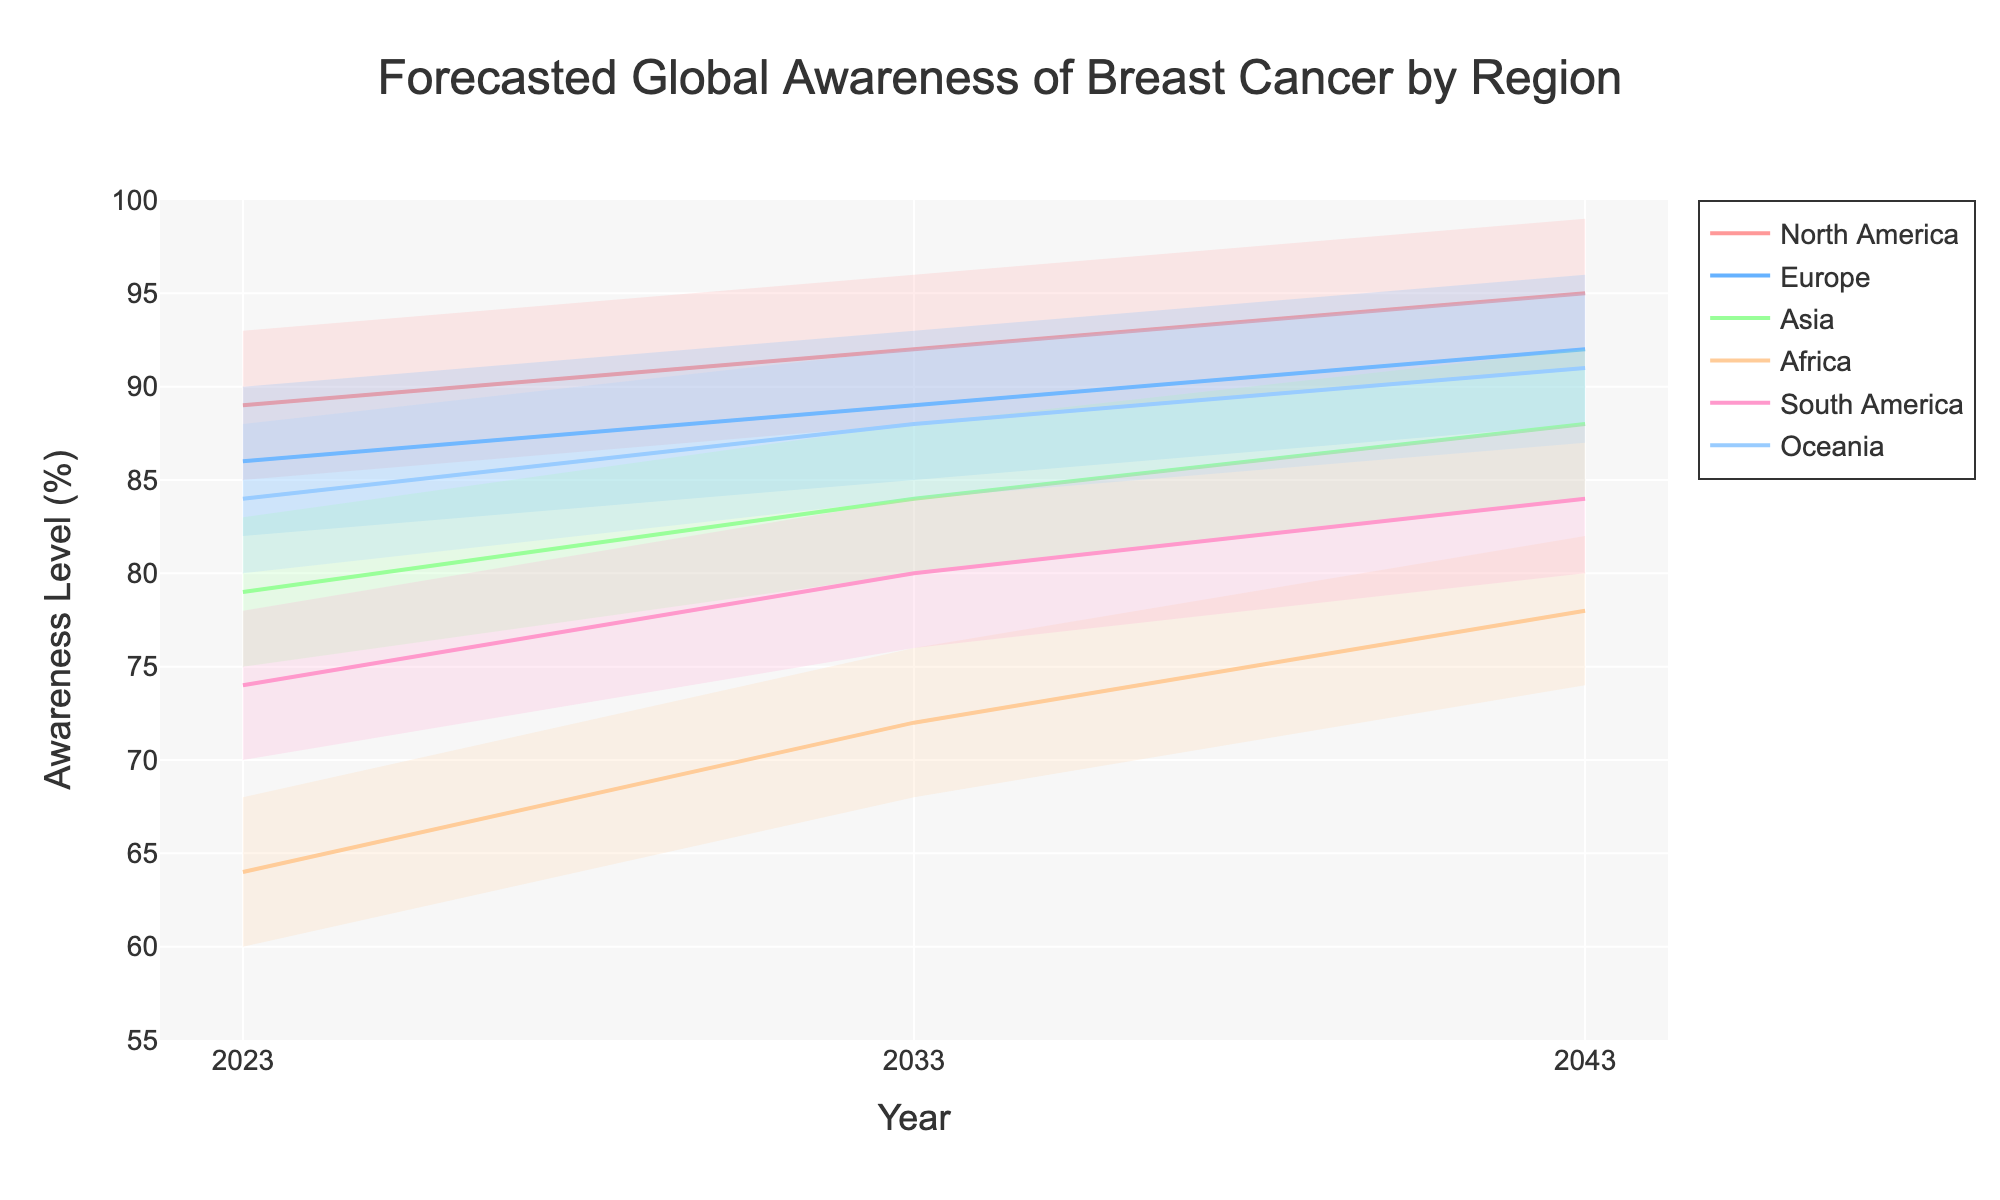What is the title of the chart? The chart title is usually located at the top-center and is written in a larger font. By looking at the top of the chart, we can see that the title is "Forecasted Global Awareness of Breast Cancer by Region".
Answer: Forecasted Global Awareness of Breast Cancer by Region Which region has the highest median awareness level in 2043? To find the highest median awareness level, we need to look at the mid-point values for each region in the year 2043. North America has a mid-point awareness level of 95, which is the highest among all regions.
Answer: North America What trend do you notice for breast cancer awareness levels in Africa from 2023 to 2043? By examining the mid-point values for Africa across the years, we can see an upward trend: 64 in 2023, 72 in 2033, and 78 in 2043. This indicates a steady increase in breast cancer awareness over the 20-year period.
Answer: Increasing trend Which region shows the least amount of increase in awareness levels from 2023 to 2043? To determine which region has the least increase, we need to calculate the difference between 2043 and 2023 mid-point values for each region. For North America: 95 - 89 = 6, Europe: 92 - 86 = 6, Asia: 88 - 79 = 9, Africa: 78 - 64 = 14, South America: 84 - 74 = 10, Oceania: 91 - 84 = 7.  Both North America and Europe have the smallest increase of 6.
Answer: North America and Europe In 2033, which region has the greatest range between the lowest and highest confidence intervals? To find the greatest range, subtract the Low value from the High value for each region in 2033. North America: 96-88=8, Europe: 93-85=8, Asia: 88-80=8, Africa: 76-68=8, South America: 84-76=8, Oceania: 92-84=8. All regions in 2033 have a range of 8 percentage points.
Answer: All regions How does the forecasted breast cancer awareness in Asia change from 2023 to 2043? By analyzing the mid-point values for Asia, we can see that the awareness level increases from 79 in 2023 to 88 in 2043, indicating a rise in awareness over 20 years.
Answer: Increases Among all regions, which one has the lowest mid-point awareness level in 2023 and by how much? Comparing the mid-point values for all regions in 2023, Africa has the lowest mid-point awareness level of 64.
Answer: Africa, 64 What is the overall percentage change in awareness level for South America from 2023 to 2043? To find the percentage change, we subtract the 2023 value from the 2043 value, then divide by the 2023 value and multiply by 100. (84 - 74) / 74 * 100 = 13.51%
Answer: 13.51% What's the average mid-point awareness level across all regions in 2043? Add the mid-point values for all regions in 2043 and divide by the number of regions: (95 + 92 + 88 + 78 + 84 + 91) / 6 = 88
Answer: 88 